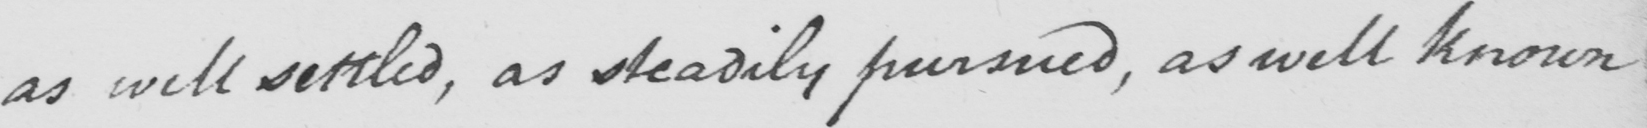What text is written in this handwritten line? as well settled , as steadily pursued , as well known 